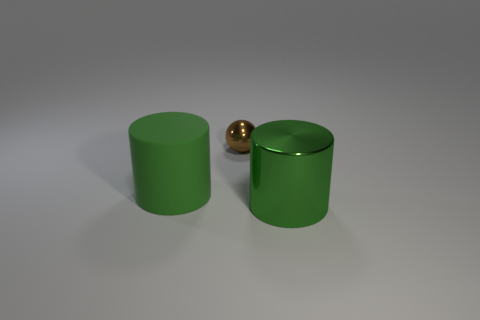What number of small brown metallic objects are behind the big object that is on the right side of the small brown metal sphere?
Keep it short and to the point. 1. There is another big green thing that is the same shape as the matte thing; what is it made of?
Provide a short and direct response. Metal. What number of brown objects are tiny things or large shiny cylinders?
Give a very brief answer. 1. Is there anything else of the same color as the small thing?
Make the answer very short. No. There is a large thing that is to the left of the large green cylinder that is in front of the large green rubber cylinder; what color is it?
Offer a terse response. Green. Is the number of green metal things on the left side of the small brown sphere less than the number of big green objects that are in front of the green shiny object?
Offer a very short reply. No. There is a cylinder that is the same color as the big shiny object; what is its material?
Your response must be concise. Rubber. How many objects are either big green cylinders to the right of the large green matte cylinder or small brown spheres?
Offer a terse response. 2. Is the size of the green cylinder right of the green rubber cylinder the same as the tiny ball?
Provide a succinct answer. No. Are there fewer big green cylinders behind the small brown ball than brown objects?
Provide a succinct answer. Yes. 